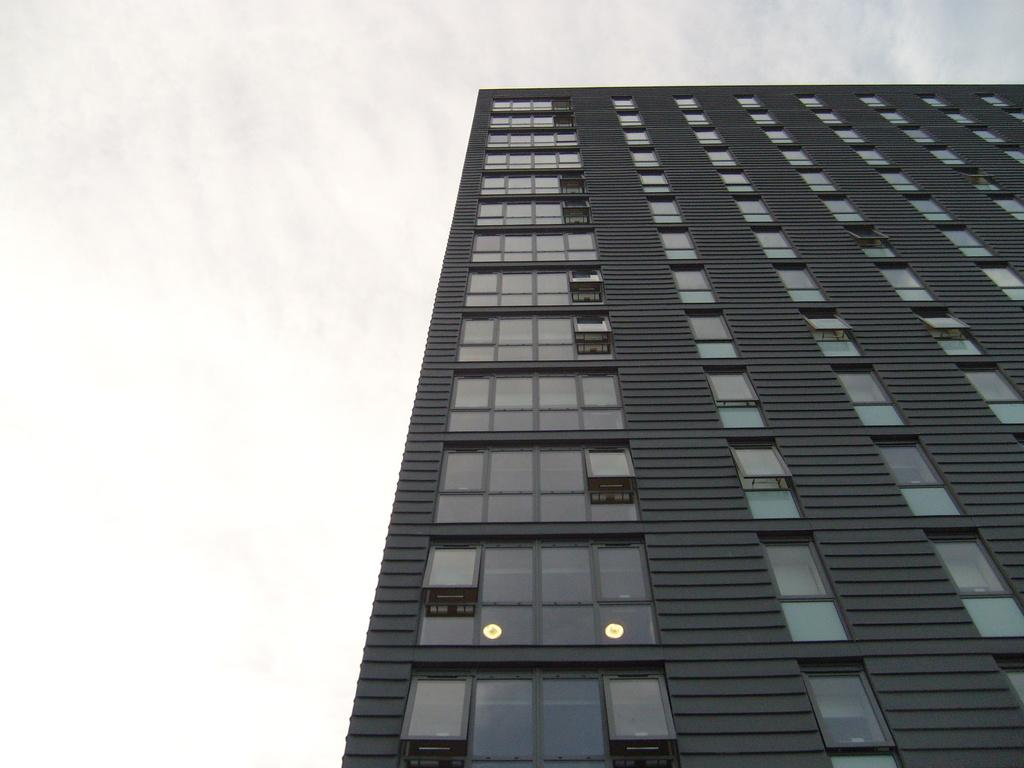What type of structure is present in the image? There is a building in the image. What can be seen in the background of the image? The sky is visible in the background of the image. What is the chance of a light bulb falling from the sky in the image? There is no light bulb present in the image, and therefore no chance of it falling from the sky. What is the mass of the building in the image? The mass of the building cannot be determined from the image alone, as it requires additional information and measurements. 